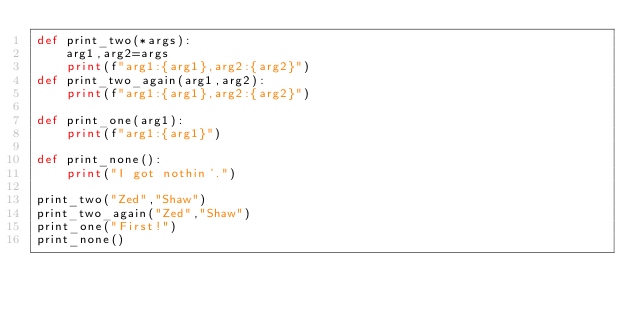Convert code to text. <code><loc_0><loc_0><loc_500><loc_500><_Python_>def print_two(*args):
    arg1,arg2=args
    print(f"arg1:{arg1},arg2:{arg2}")
def print_two_again(arg1,arg2):
    print(f"arg1:{arg1},arg2:{arg2}")

def print_one(arg1):
    print(f"arg1:{arg1}")

def print_none():
    print("I got nothin'.")

print_two("Zed","Shaw")
print_two_again("Zed","Shaw")
print_one("First!")
print_none()


</code> 